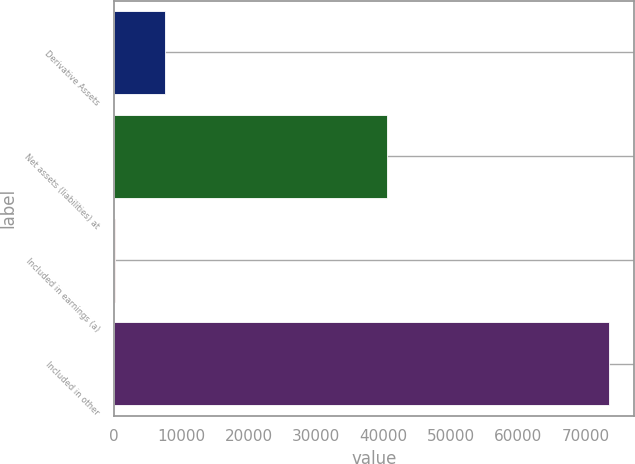<chart> <loc_0><loc_0><loc_500><loc_500><bar_chart><fcel>Derivative Assets<fcel>Net assets (liabilities) at<fcel>Included in earnings (a)<fcel>Included in other<nl><fcel>7472.2<fcel>40484<fcel>140<fcel>73462<nl></chart> 